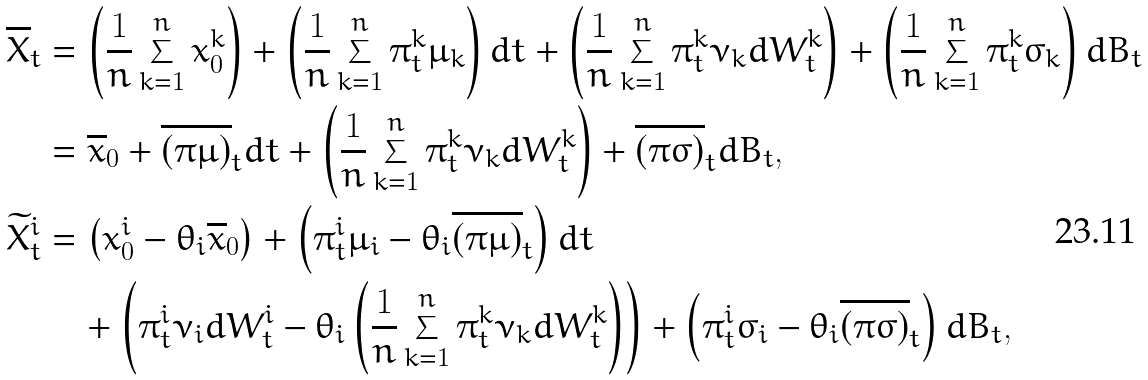<formula> <loc_0><loc_0><loc_500><loc_500>\overline { X } _ { t } & = \left ( \frac { 1 } { n } \sum _ { k = 1 } ^ { n } x _ { 0 } ^ { k } \right ) + \left ( \frac { 1 } { n } \sum _ { k = 1 } ^ { n } \pi _ { t } ^ { k } \mu _ { k } \right ) d t + \left ( \frac { 1 } { n } \sum _ { k = 1 } ^ { n } \pi _ { t } ^ { k } \nu _ { k } d W _ { t } ^ { k } \right ) + \left ( \frac { 1 } { n } \sum _ { k = 1 } ^ { n } \pi _ { t } ^ { k } \sigma _ { k } \right ) d B _ { t } \\ & = \overline { x } _ { 0 } + \overline { ( \pi \mu ) } _ { t } d t + \left ( \frac { 1 } { n } \sum _ { k = 1 } ^ { n } \pi _ { t } ^ { k } \nu _ { k } d W _ { t } ^ { k } \right ) + \overline { ( \pi \sigma ) } _ { t } d B _ { t } , \\ \widetilde { X } ^ { i } _ { t } & = \left ( x ^ { i } _ { 0 } - \theta _ { i } \overline { x } _ { 0 } \right ) + \left ( \pi _ { t } ^ { i } \mu _ { i } - \theta _ { i } \overline { ( \pi \mu ) } _ { t } \right ) d t \\ & \quad + \left ( \pi _ { t } ^ { i } \nu _ { i } d W _ { t } ^ { i } - \theta _ { i } \left ( \frac { 1 } { n } \sum _ { k = 1 } ^ { n } \pi _ { t } ^ { k } \nu _ { k } d W _ { t } ^ { k } \right ) \right ) + \left ( \pi _ { t } ^ { i } \sigma _ { i } - \theta _ { i } \overline { ( \pi \sigma ) } _ { t } \right ) d B _ { t } ,</formula> 